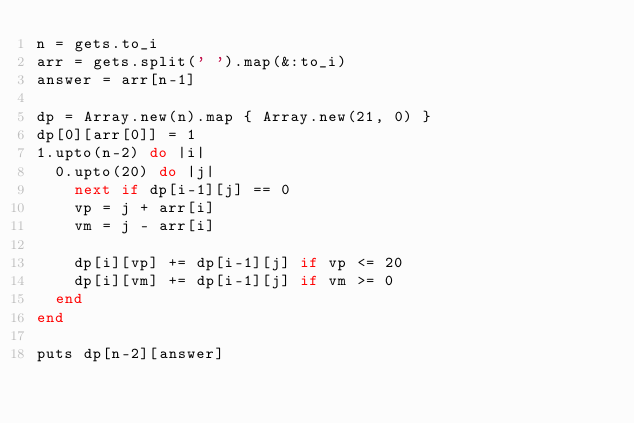Convert code to text. <code><loc_0><loc_0><loc_500><loc_500><_Ruby_>n = gets.to_i
arr = gets.split(' ').map(&:to_i)
answer = arr[n-1]

dp = Array.new(n).map { Array.new(21, 0) }
dp[0][arr[0]] = 1
1.upto(n-2) do |i|
  0.upto(20) do |j|
    next if dp[i-1][j] == 0
    vp = j + arr[i]
    vm = j - arr[i]

    dp[i][vp] += dp[i-1][j] if vp <= 20
    dp[i][vm] += dp[i-1][j] if vm >= 0
  end
end

puts dp[n-2][answer]</code> 